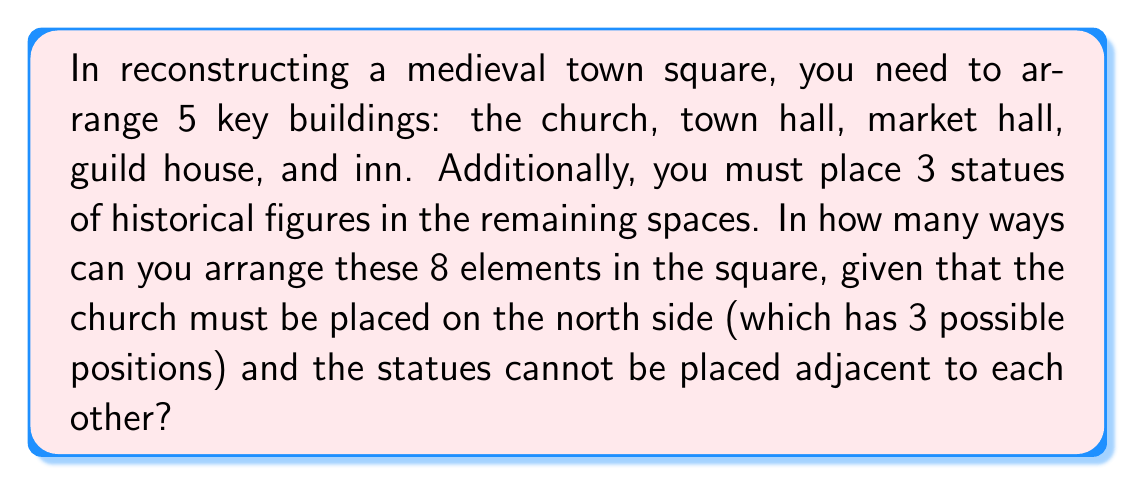Teach me how to tackle this problem. Let's approach this step-by-step:

1) First, we need to place the church. It has 3 possible positions on the north side.

2) After placing the church, we have 7 elements left to arrange in 7 spaces.

3) We need to ensure the statues are not adjacent. To do this, we can consider the statues and the other buildings as units to be arranged, with the condition that we'll insert the other two statues in the gaps later.

4) So now we have 5 units to arrange: 4 buildings and 1 statue (considered as a unit).
   This can be done in $5! = 120$ ways.

5) After this arrangement, we have 4 gaps where we can insert the remaining 2 statues (between the 5 units and at the end). We need to choose 2 out of these 4 gaps.
   This can be done in $\binom{4}{2} = 6$ ways.

6) By the multiplication principle, for each of the 3 church positions, we have $120 * 6 = 720$ arrangements.

7) Therefore, the total number of possible arrangements is:

   $$ 3 * 720 = 2160 $$
Answer: 2160 